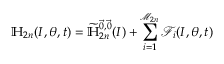<formula> <loc_0><loc_0><loc_500><loc_500>\mathbb { H } _ { 2 n } ( I , \theta , t ) = \widetilde { \mathbb { H } } _ { 2 n } ^ { \vec { 0 } , \vec { 0 } } ( I ) + \sum _ { i = 1 } ^ { \mathcal { M } _ { 2 n } } \mathcal { F } _ { i } ( I , \theta , t )</formula> 